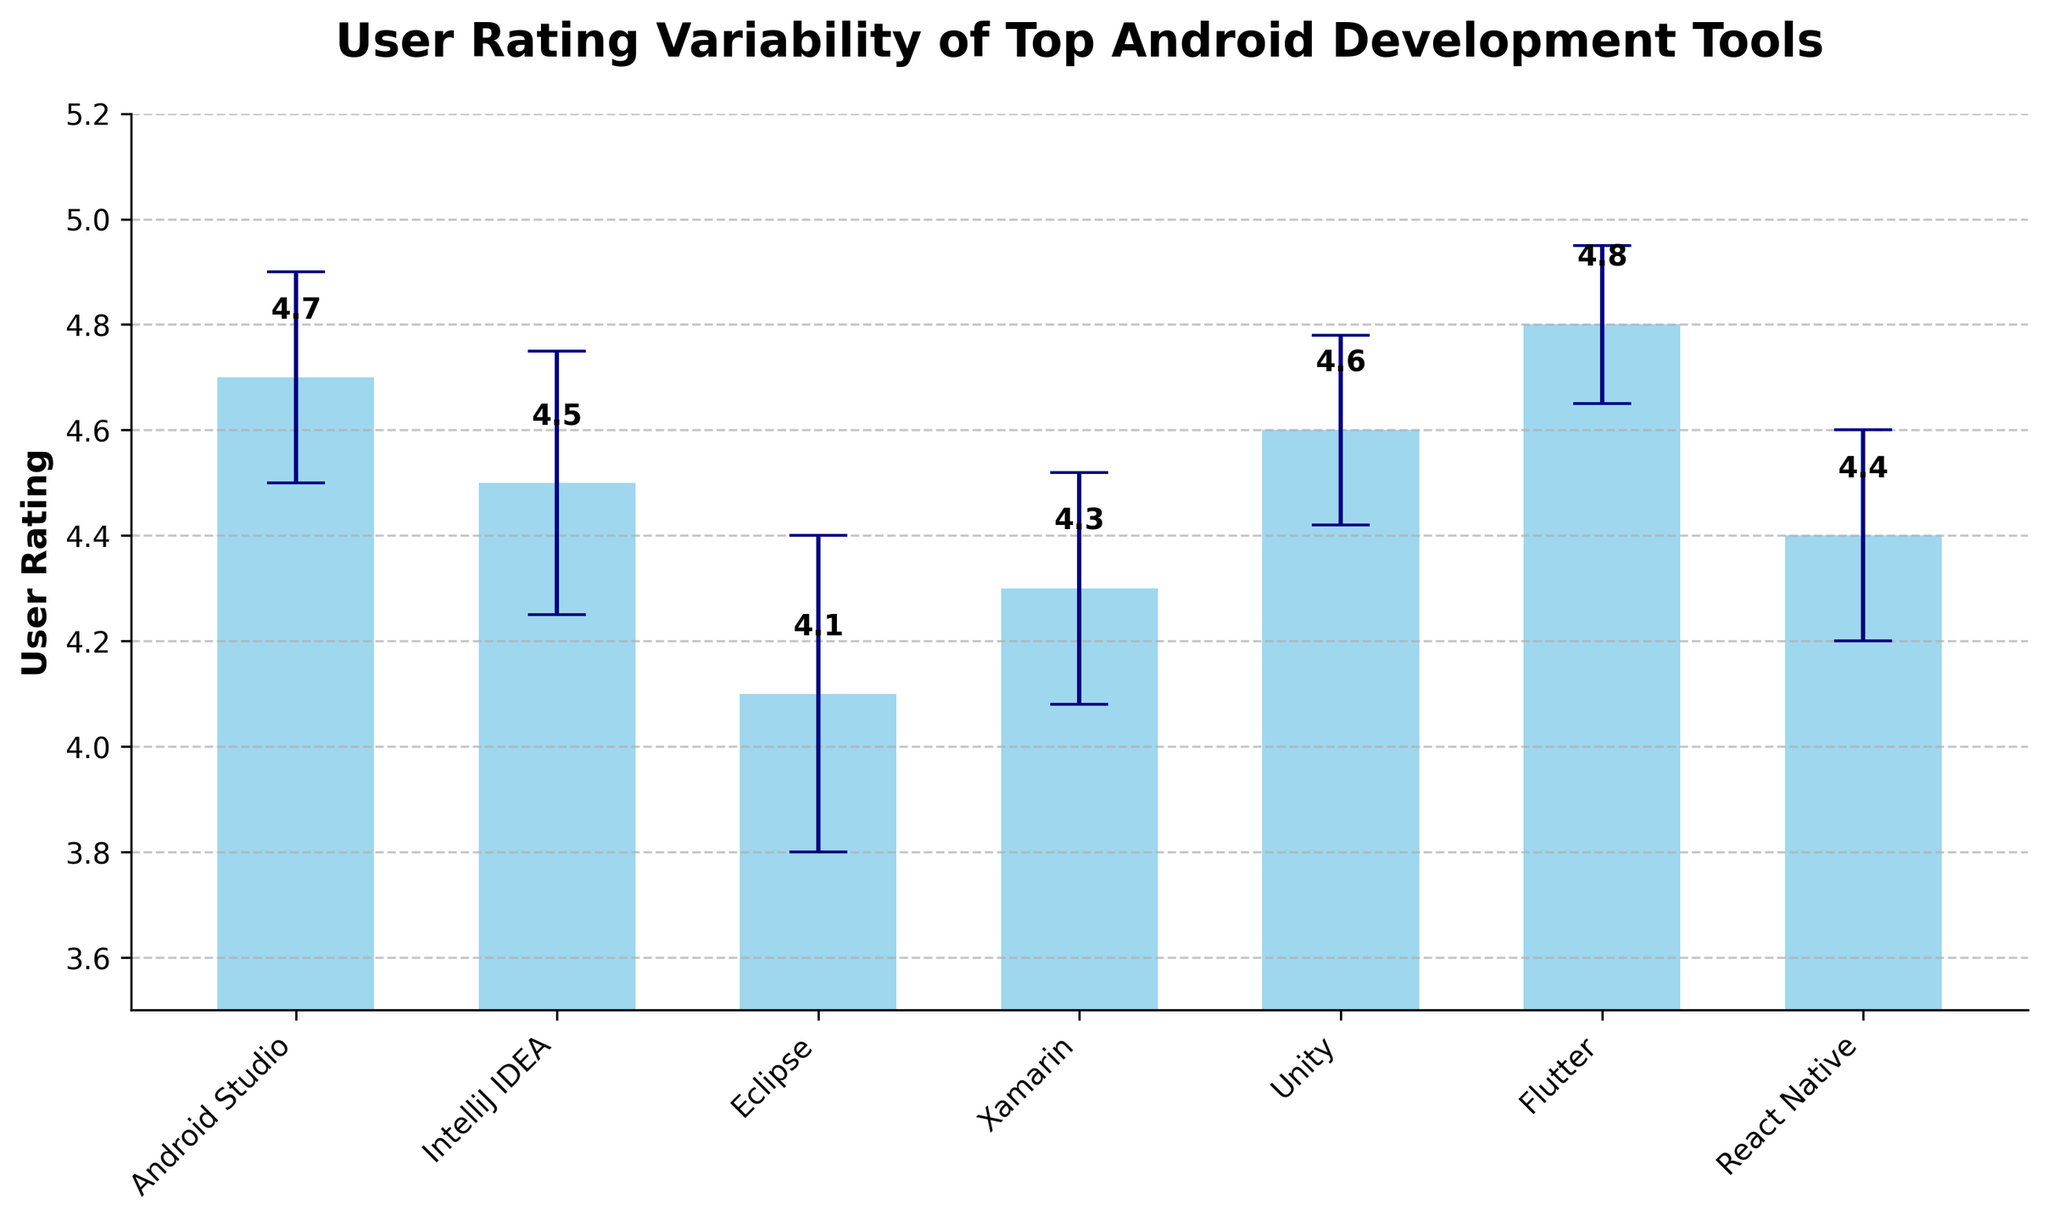What's the title of the figure? The title of the figure is typically found at the top and is intended to provide an overview of the content. In this case, the title is explicitly set in the code.
Answer: User Rating Variability of Top Android Development Tools How many development tools are displayed in the figure? The number of tools displayed in the figure corresponds to the number of bars in the bar chart. Each bar represents one development tool. In the code, 7 tools are plotted.
Answer: 7 Which tool has the highest user rating? To determine the highest user rating, look at the y-values represented by the top of each bar. The tallest bar will indicate the highest user rating. In this chart, Flutter has the tallest bar with a rating of 4.8.
Answer: Flutter Which tool has the largest standard error? Standard error is represented by the error bars extending above and below each bar. The tool with the longest error bars has the largest standard error. According to the data, Eclipse has the largest standard error of 0.3.
Answer: Eclipse Compare the user ratings of Android Studio and Unity. Which one is higher and by how much? Find the corresponding bars for Android Studio and Unity. Android Studio has a rating of 4.7, and Unity has a rating of 4.6. Subtract Unity's rating from Android Studio’s rating.
Answer: Android Studio is higher by 0.1 What's the average user rating of all the tools combined? To find the average, sum all the ratings and divide by the number of tools. Sum: 4.7 + 4.5 + 4.1 + 4.3 + 4.6 + 4.8 + 4.4 = 31.4. Average: 31.4 / 7 = 4.49.
Answer: 4.49 Which tools have overlapping confidence intervals? Overlapping confidence intervals occur when the error bars of two tools intersect. Visually compare the error bars of each tool to identify intersections. Here, Android Studio & IntelliJ IDEA, and Unity & Xamarin have overlapping intervals.
Answer: Android Studio and IntelliJ IDEA, Unity and Xamarin Rank the tools by user rating from highest to lowest. To rank the tools, list them in descending order based on the height of their bars representing user ratings.
Answer: Flutter, Android Studio, Unity, IntelliJ IDEA, React Native, Xamarin, Eclipse What's the difference in user rating between the tool with the highest and the tool with the lowest user rating? Identify the highest and lowest ratings from the bars. Flutter has the highest (4.8) and Eclipse has the lowest (4.1). Subtract the lowest from the highest. 4.8 - 4.1 = 0.7.
Answer: 0.7 What does the error bar represent in this figure? The error bars represent the standard error of the user rating, providing a graphical depiction of the rating's variability with 95% confidence intervals. This is indicated in the description of the plot generation.
Answer: Standard error 